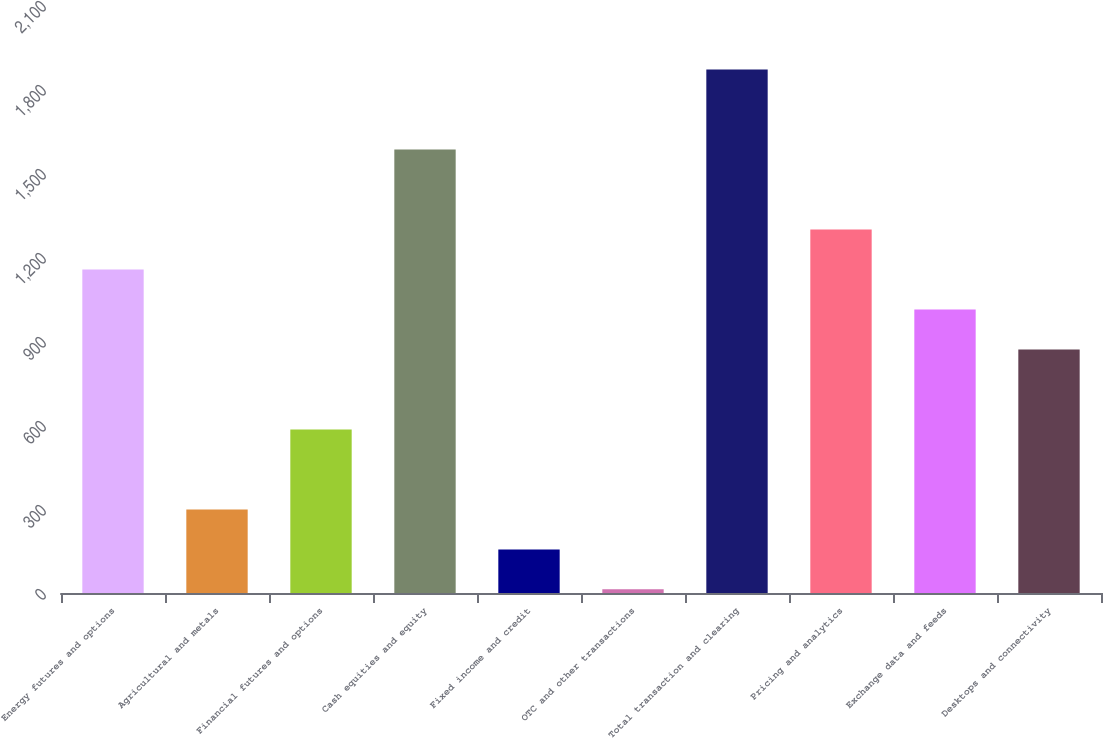Convert chart. <chart><loc_0><loc_0><loc_500><loc_500><bar_chart><fcel>Energy futures and options<fcel>Agricultural and metals<fcel>Financial futures and options<fcel>Cash equities and equity<fcel>Fixed income and credit<fcel>OTC and other transactions<fcel>Total transaction and clearing<fcel>Pricing and analytics<fcel>Exchange data and feeds<fcel>Desktops and connectivity<nl><fcel>1155.4<fcel>298.6<fcel>584.2<fcel>1583.8<fcel>155.8<fcel>13<fcel>1869.4<fcel>1298.2<fcel>1012.6<fcel>869.8<nl></chart> 